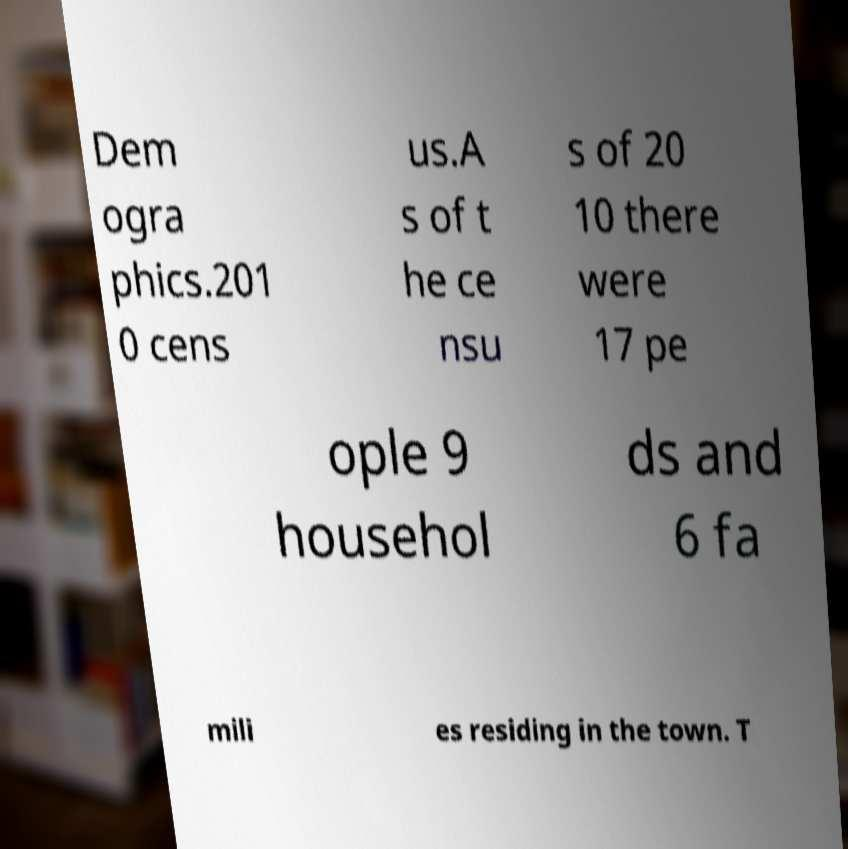For documentation purposes, I need the text within this image transcribed. Could you provide that? Dem ogra phics.201 0 cens us.A s of t he ce nsu s of 20 10 there were 17 pe ople 9 househol ds and 6 fa mili es residing in the town. T 